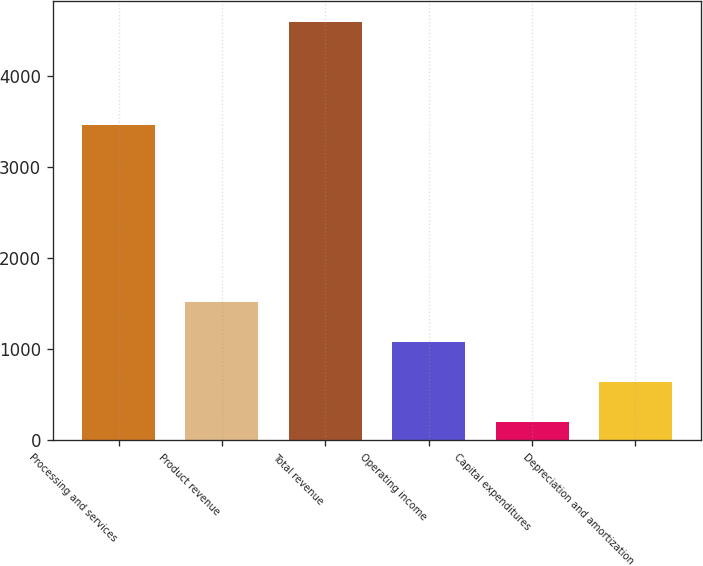Convert chart to OTSL. <chart><loc_0><loc_0><loc_500><loc_500><bar_chart><fcel>Processing and services<fcel>Product revenue<fcel>Total revenue<fcel>Operating income<fcel>Capital expenditures<fcel>Depreciation and amortization<nl><fcel>3464<fcel>1514.7<fcel>4587<fcel>1075.8<fcel>198<fcel>636.9<nl></chart> 